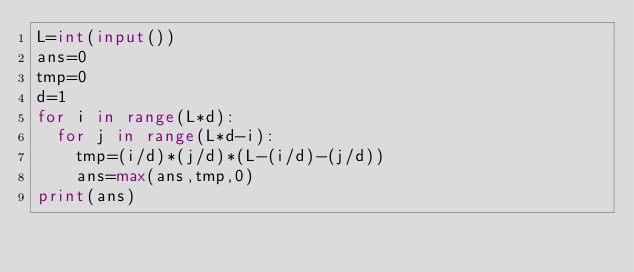Convert code to text. <code><loc_0><loc_0><loc_500><loc_500><_Python_>L=int(input())
ans=0
tmp=0
d=1
for i in range(L*d):
  for j in range(L*d-i):
    tmp=(i/d)*(j/d)*(L-(i/d)-(j/d))
    ans=max(ans,tmp,0)
print(ans)</code> 